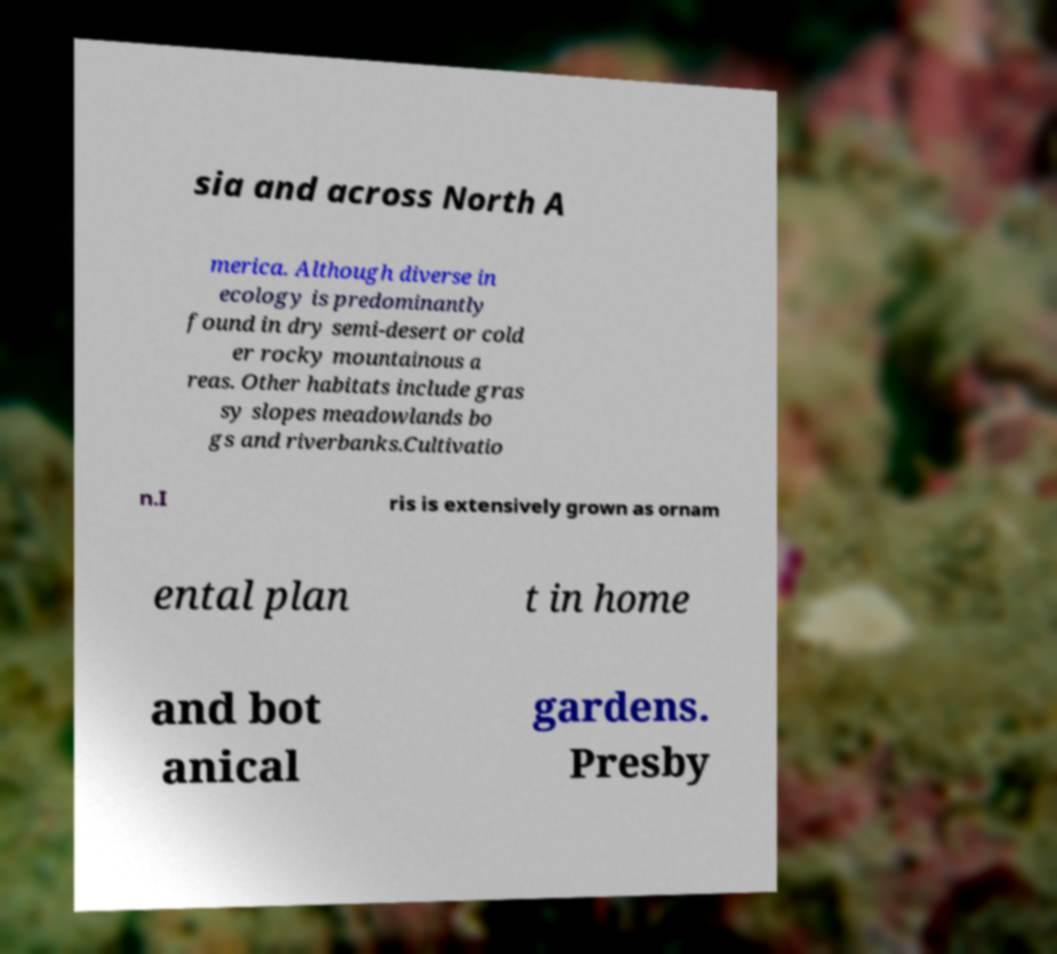There's text embedded in this image that I need extracted. Can you transcribe it verbatim? sia and across North A merica. Although diverse in ecology is predominantly found in dry semi-desert or cold er rocky mountainous a reas. Other habitats include gras sy slopes meadowlands bo gs and riverbanks.Cultivatio n.I ris is extensively grown as ornam ental plan t in home and bot anical gardens. Presby 